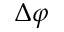<formula> <loc_0><loc_0><loc_500><loc_500>\Delta \varphi</formula> 